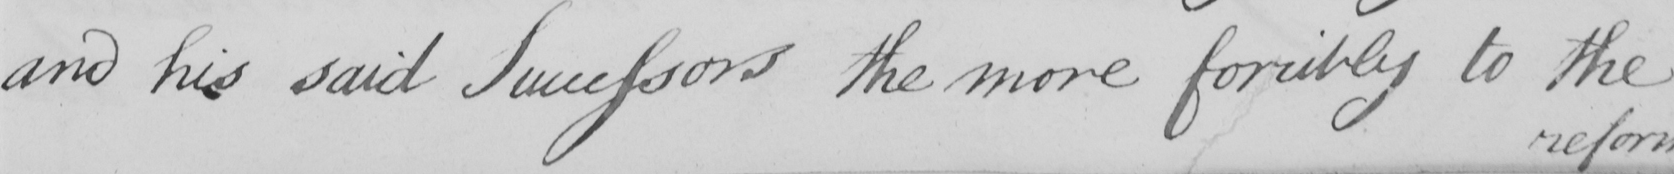Please transcribe the handwritten text in this image. and his said Successors the more forcibly to the 